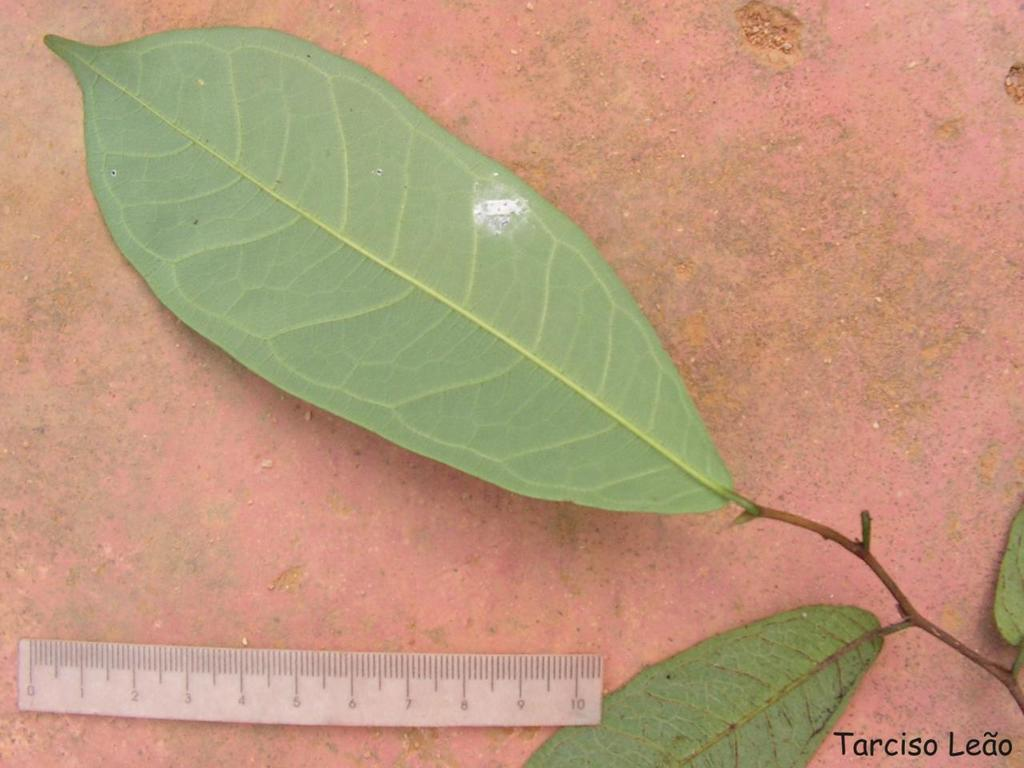<image>
Provide a brief description of the given image. Photo of a leaf near a ruler by Tarciso Leao. 